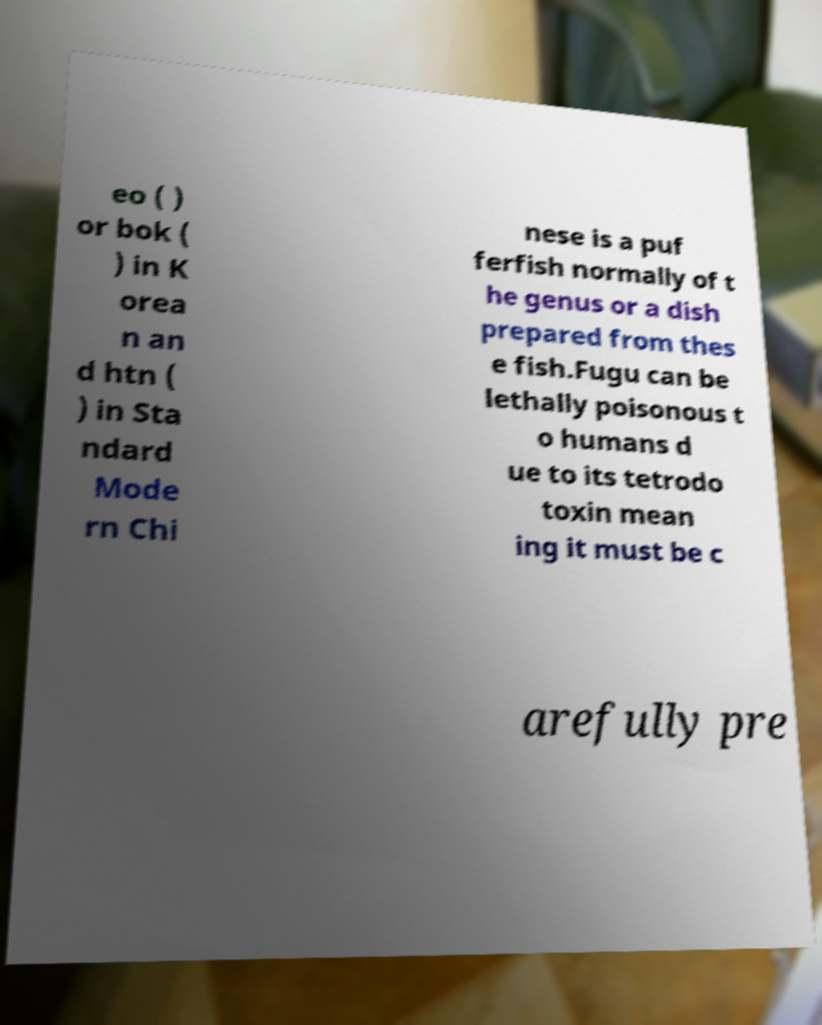Please identify and transcribe the text found in this image. eo ( ) or bok ( ) in K orea n an d htn ( ) in Sta ndard Mode rn Chi nese is a puf ferfish normally of t he genus or a dish prepared from thes e fish.Fugu can be lethally poisonous t o humans d ue to its tetrodo toxin mean ing it must be c arefully pre 